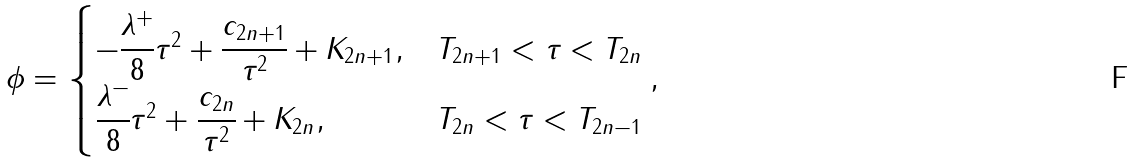Convert formula to latex. <formula><loc_0><loc_0><loc_500><loc_500>\phi = \begin{cases} - \cfrac { \lambda ^ { + } } { 8 } \tau ^ { 2 } + \cfrac { { c _ { 2 n + 1 } } } { \tau ^ { 2 } } + K _ { 2 n + 1 } , & T _ { 2 n + 1 } < \tau < T _ { 2 n } \\ \cfrac { \lambda ^ { - } } { 8 } \tau ^ { 2 } + \cfrac { { c _ { 2 n } } } { \tau ^ { 2 } } + K _ { 2 n } , & T _ { 2 n } < \tau < T _ { 2 n - 1 } \\ \end{cases} ,</formula> 